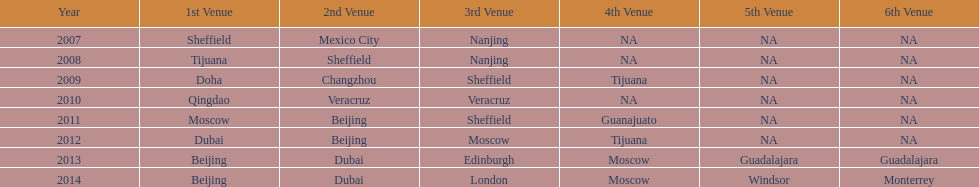When was the final year that tijuana functioned as a venue? 2012. 